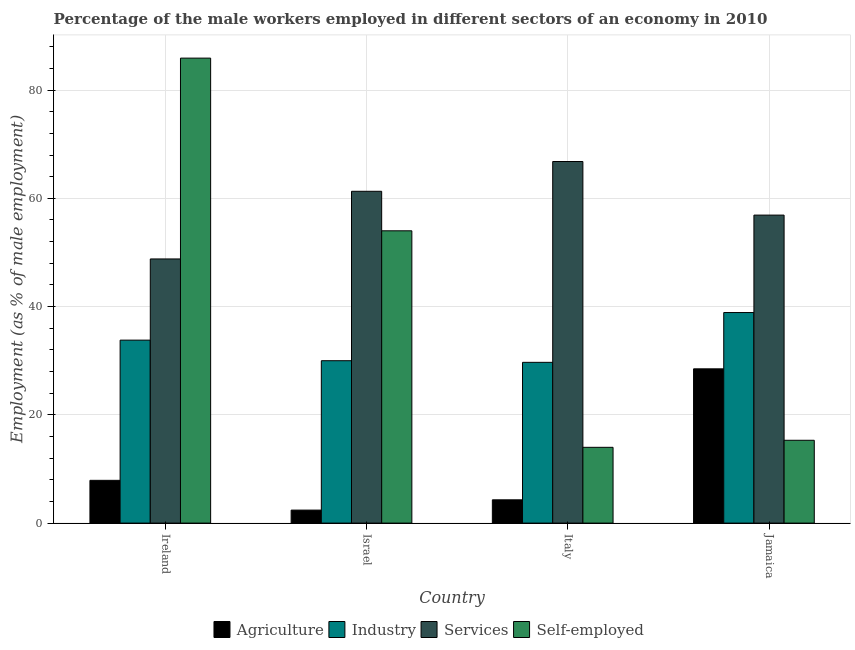How many groups of bars are there?
Your response must be concise. 4. Are the number of bars per tick equal to the number of legend labels?
Offer a very short reply. Yes. Are the number of bars on each tick of the X-axis equal?
Keep it short and to the point. Yes. How many bars are there on the 4th tick from the left?
Keep it short and to the point. 4. How many bars are there on the 1st tick from the right?
Your answer should be compact. 4. In how many cases, is the number of bars for a given country not equal to the number of legend labels?
Give a very brief answer. 0. What is the percentage of male workers in agriculture in Israel?
Give a very brief answer. 2.4. Across all countries, what is the maximum percentage of self employed male workers?
Your answer should be compact. 85.9. Across all countries, what is the minimum percentage of male workers in industry?
Make the answer very short. 29.7. What is the total percentage of male workers in agriculture in the graph?
Offer a very short reply. 43.1. What is the difference between the percentage of male workers in industry in Israel and that in Italy?
Make the answer very short. 0.3. What is the difference between the percentage of self employed male workers in Israel and the percentage of male workers in agriculture in Jamaica?
Give a very brief answer. 25.5. What is the average percentage of male workers in industry per country?
Keep it short and to the point. 33.1. What is the difference between the percentage of male workers in services and percentage of male workers in industry in Israel?
Offer a terse response. 31.3. In how many countries, is the percentage of male workers in industry greater than 76 %?
Offer a terse response. 0. What is the ratio of the percentage of self employed male workers in Ireland to that in Italy?
Offer a very short reply. 6.14. Is the percentage of male workers in industry in Israel less than that in Italy?
Your answer should be compact. No. Is the difference between the percentage of male workers in agriculture in Israel and Jamaica greater than the difference between the percentage of self employed male workers in Israel and Jamaica?
Make the answer very short. No. What is the difference between the highest and the second highest percentage of male workers in industry?
Ensure brevity in your answer.  5.1. What is the difference between the highest and the lowest percentage of self employed male workers?
Give a very brief answer. 71.9. What does the 3rd bar from the left in Jamaica represents?
Ensure brevity in your answer.  Services. What does the 2nd bar from the right in Jamaica represents?
Your answer should be compact. Services. Is it the case that in every country, the sum of the percentage of male workers in agriculture and percentage of male workers in industry is greater than the percentage of male workers in services?
Give a very brief answer. No. How many bars are there?
Offer a terse response. 16. Are all the bars in the graph horizontal?
Provide a succinct answer. No. How many countries are there in the graph?
Your answer should be compact. 4. What is the difference between two consecutive major ticks on the Y-axis?
Ensure brevity in your answer.  20. Are the values on the major ticks of Y-axis written in scientific E-notation?
Your answer should be compact. No. Does the graph contain any zero values?
Provide a short and direct response. No. How are the legend labels stacked?
Keep it short and to the point. Horizontal. What is the title of the graph?
Make the answer very short. Percentage of the male workers employed in different sectors of an economy in 2010. What is the label or title of the X-axis?
Your answer should be very brief. Country. What is the label or title of the Y-axis?
Your answer should be compact. Employment (as % of male employment). What is the Employment (as % of male employment) in Agriculture in Ireland?
Provide a short and direct response. 7.9. What is the Employment (as % of male employment) in Industry in Ireland?
Ensure brevity in your answer.  33.8. What is the Employment (as % of male employment) in Services in Ireland?
Provide a succinct answer. 48.8. What is the Employment (as % of male employment) in Self-employed in Ireland?
Ensure brevity in your answer.  85.9. What is the Employment (as % of male employment) in Agriculture in Israel?
Offer a terse response. 2.4. What is the Employment (as % of male employment) of Industry in Israel?
Keep it short and to the point. 30. What is the Employment (as % of male employment) in Services in Israel?
Offer a very short reply. 61.3. What is the Employment (as % of male employment) in Agriculture in Italy?
Ensure brevity in your answer.  4.3. What is the Employment (as % of male employment) of Industry in Italy?
Give a very brief answer. 29.7. What is the Employment (as % of male employment) of Services in Italy?
Ensure brevity in your answer.  66.8. What is the Employment (as % of male employment) in Industry in Jamaica?
Offer a terse response. 38.9. What is the Employment (as % of male employment) in Services in Jamaica?
Provide a succinct answer. 56.9. What is the Employment (as % of male employment) of Self-employed in Jamaica?
Your answer should be compact. 15.3. Across all countries, what is the maximum Employment (as % of male employment) in Industry?
Ensure brevity in your answer.  38.9. Across all countries, what is the maximum Employment (as % of male employment) in Services?
Provide a short and direct response. 66.8. Across all countries, what is the maximum Employment (as % of male employment) of Self-employed?
Offer a terse response. 85.9. Across all countries, what is the minimum Employment (as % of male employment) of Agriculture?
Provide a short and direct response. 2.4. Across all countries, what is the minimum Employment (as % of male employment) of Industry?
Your answer should be compact. 29.7. Across all countries, what is the minimum Employment (as % of male employment) of Services?
Ensure brevity in your answer.  48.8. What is the total Employment (as % of male employment) in Agriculture in the graph?
Keep it short and to the point. 43.1. What is the total Employment (as % of male employment) in Industry in the graph?
Keep it short and to the point. 132.4. What is the total Employment (as % of male employment) of Services in the graph?
Provide a short and direct response. 233.8. What is the total Employment (as % of male employment) of Self-employed in the graph?
Ensure brevity in your answer.  169.2. What is the difference between the Employment (as % of male employment) in Agriculture in Ireland and that in Israel?
Your answer should be compact. 5.5. What is the difference between the Employment (as % of male employment) of Services in Ireland and that in Israel?
Make the answer very short. -12.5. What is the difference between the Employment (as % of male employment) in Self-employed in Ireland and that in Israel?
Make the answer very short. 31.9. What is the difference between the Employment (as % of male employment) in Industry in Ireland and that in Italy?
Give a very brief answer. 4.1. What is the difference between the Employment (as % of male employment) of Self-employed in Ireland and that in Italy?
Keep it short and to the point. 71.9. What is the difference between the Employment (as % of male employment) of Agriculture in Ireland and that in Jamaica?
Give a very brief answer. -20.6. What is the difference between the Employment (as % of male employment) of Self-employed in Ireland and that in Jamaica?
Offer a very short reply. 70.6. What is the difference between the Employment (as % of male employment) of Agriculture in Israel and that in Italy?
Provide a short and direct response. -1.9. What is the difference between the Employment (as % of male employment) of Industry in Israel and that in Italy?
Offer a terse response. 0.3. What is the difference between the Employment (as % of male employment) of Services in Israel and that in Italy?
Your answer should be very brief. -5.5. What is the difference between the Employment (as % of male employment) of Self-employed in Israel and that in Italy?
Make the answer very short. 40. What is the difference between the Employment (as % of male employment) of Agriculture in Israel and that in Jamaica?
Your answer should be compact. -26.1. What is the difference between the Employment (as % of male employment) of Services in Israel and that in Jamaica?
Offer a terse response. 4.4. What is the difference between the Employment (as % of male employment) of Self-employed in Israel and that in Jamaica?
Offer a very short reply. 38.7. What is the difference between the Employment (as % of male employment) of Agriculture in Italy and that in Jamaica?
Give a very brief answer. -24.2. What is the difference between the Employment (as % of male employment) in Agriculture in Ireland and the Employment (as % of male employment) in Industry in Israel?
Offer a very short reply. -22.1. What is the difference between the Employment (as % of male employment) of Agriculture in Ireland and the Employment (as % of male employment) of Services in Israel?
Your answer should be compact. -53.4. What is the difference between the Employment (as % of male employment) of Agriculture in Ireland and the Employment (as % of male employment) of Self-employed in Israel?
Ensure brevity in your answer.  -46.1. What is the difference between the Employment (as % of male employment) in Industry in Ireland and the Employment (as % of male employment) in Services in Israel?
Offer a terse response. -27.5. What is the difference between the Employment (as % of male employment) in Industry in Ireland and the Employment (as % of male employment) in Self-employed in Israel?
Your answer should be compact. -20.2. What is the difference between the Employment (as % of male employment) in Agriculture in Ireland and the Employment (as % of male employment) in Industry in Italy?
Give a very brief answer. -21.8. What is the difference between the Employment (as % of male employment) of Agriculture in Ireland and the Employment (as % of male employment) of Services in Italy?
Provide a succinct answer. -58.9. What is the difference between the Employment (as % of male employment) in Agriculture in Ireland and the Employment (as % of male employment) in Self-employed in Italy?
Provide a succinct answer. -6.1. What is the difference between the Employment (as % of male employment) in Industry in Ireland and the Employment (as % of male employment) in Services in Italy?
Your response must be concise. -33. What is the difference between the Employment (as % of male employment) in Industry in Ireland and the Employment (as % of male employment) in Self-employed in Italy?
Provide a short and direct response. 19.8. What is the difference between the Employment (as % of male employment) in Services in Ireland and the Employment (as % of male employment) in Self-employed in Italy?
Ensure brevity in your answer.  34.8. What is the difference between the Employment (as % of male employment) in Agriculture in Ireland and the Employment (as % of male employment) in Industry in Jamaica?
Make the answer very short. -31. What is the difference between the Employment (as % of male employment) of Agriculture in Ireland and the Employment (as % of male employment) of Services in Jamaica?
Your answer should be compact. -49. What is the difference between the Employment (as % of male employment) in Industry in Ireland and the Employment (as % of male employment) in Services in Jamaica?
Your answer should be very brief. -23.1. What is the difference between the Employment (as % of male employment) of Services in Ireland and the Employment (as % of male employment) of Self-employed in Jamaica?
Make the answer very short. 33.5. What is the difference between the Employment (as % of male employment) of Agriculture in Israel and the Employment (as % of male employment) of Industry in Italy?
Provide a short and direct response. -27.3. What is the difference between the Employment (as % of male employment) of Agriculture in Israel and the Employment (as % of male employment) of Services in Italy?
Your answer should be compact. -64.4. What is the difference between the Employment (as % of male employment) of Agriculture in Israel and the Employment (as % of male employment) of Self-employed in Italy?
Keep it short and to the point. -11.6. What is the difference between the Employment (as % of male employment) of Industry in Israel and the Employment (as % of male employment) of Services in Italy?
Offer a terse response. -36.8. What is the difference between the Employment (as % of male employment) of Services in Israel and the Employment (as % of male employment) of Self-employed in Italy?
Offer a terse response. 47.3. What is the difference between the Employment (as % of male employment) in Agriculture in Israel and the Employment (as % of male employment) in Industry in Jamaica?
Provide a short and direct response. -36.5. What is the difference between the Employment (as % of male employment) of Agriculture in Israel and the Employment (as % of male employment) of Services in Jamaica?
Your answer should be compact. -54.5. What is the difference between the Employment (as % of male employment) of Agriculture in Israel and the Employment (as % of male employment) of Self-employed in Jamaica?
Keep it short and to the point. -12.9. What is the difference between the Employment (as % of male employment) of Industry in Israel and the Employment (as % of male employment) of Services in Jamaica?
Keep it short and to the point. -26.9. What is the difference between the Employment (as % of male employment) in Services in Israel and the Employment (as % of male employment) in Self-employed in Jamaica?
Make the answer very short. 46. What is the difference between the Employment (as % of male employment) in Agriculture in Italy and the Employment (as % of male employment) in Industry in Jamaica?
Ensure brevity in your answer.  -34.6. What is the difference between the Employment (as % of male employment) in Agriculture in Italy and the Employment (as % of male employment) in Services in Jamaica?
Give a very brief answer. -52.6. What is the difference between the Employment (as % of male employment) of Agriculture in Italy and the Employment (as % of male employment) of Self-employed in Jamaica?
Keep it short and to the point. -11. What is the difference between the Employment (as % of male employment) in Industry in Italy and the Employment (as % of male employment) in Services in Jamaica?
Offer a very short reply. -27.2. What is the difference between the Employment (as % of male employment) of Services in Italy and the Employment (as % of male employment) of Self-employed in Jamaica?
Offer a very short reply. 51.5. What is the average Employment (as % of male employment) in Agriculture per country?
Your answer should be very brief. 10.78. What is the average Employment (as % of male employment) in Industry per country?
Offer a very short reply. 33.1. What is the average Employment (as % of male employment) in Services per country?
Keep it short and to the point. 58.45. What is the average Employment (as % of male employment) in Self-employed per country?
Your response must be concise. 42.3. What is the difference between the Employment (as % of male employment) in Agriculture and Employment (as % of male employment) in Industry in Ireland?
Give a very brief answer. -25.9. What is the difference between the Employment (as % of male employment) of Agriculture and Employment (as % of male employment) of Services in Ireland?
Provide a succinct answer. -40.9. What is the difference between the Employment (as % of male employment) of Agriculture and Employment (as % of male employment) of Self-employed in Ireland?
Your answer should be compact. -78. What is the difference between the Employment (as % of male employment) of Industry and Employment (as % of male employment) of Services in Ireland?
Ensure brevity in your answer.  -15. What is the difference between the Employment (as % of male employment) of Industry and Employment (as % of male employment) of Self-employed in Ireland?
Your response must be concise. -52.1. What is the difference between the Employment (as % of male employment) in Services and Employment (as % of male employment) in Self-employed in Ireland?
Make the answer very short. -37.1. What is the difference between the Employment (as % of male employment) of Agriculture and Employment (as % of male employment) of Industry in Israel?
Keep it short and to the point. -27.6. What is the difference between the Employment (as % of male employment) in Agriculture and Employment (as % of male employment) in Services in Israel?
Offer a terse response. -58.9. What is the difference between the Employment (as % of male employment) of Agriculture and Employment (as % of male employment) of Self-employed in Israel?
Provide a succinct answer. -51.6. What is the difference between the Employment (as % of male employment) in Industry and Employment (as % of male employment) in Services in Israel?
Keep it short and to the point. -31.3. What is the difference between the Employment (as % of male employment) of Industry and Employment (as % of male employment) of Self-employed in Israel?
Offer a terse response. -24. What is the difference between the Employment (as % of male employment) in Services and Employment (as % of male employment) in Self-employed in Israel?
Keep it short and to the point. 7.3. What is the difference between the Employment (as % of male employment) in Agriculture and Employment (as % of male employment) in Industry in Italy?
Make the answer very short. -25.4. What is the difference between the Employment (as % of male employment) of Agriculture and Employment (as % of male employment) of Services in Italy?
Give a very brief answer. -62.5. What is the difference between the Employment (as % of male employment) of Agriculture and Employment (as % of male employment) of Self-employed in Italy?
Your answer should be compact. -9.7. What is the difference between the Employment (as % of male employment) of Industry and Employment (as % of male employment) of Services in Italy?
Offer a very short reply. -37.1. What is the difference between the Employment (as % of male employment) of Industry and Employment (as % of male employment) of Self-employed in Italy?
Your answer should be very brief. 15.7. What is the difference between the Employment (as % of male employment) of Services and Employment (as % of male employment) of Self-employed in Italy?
Your answer should be very brief. 52.8. What is the difference between the Employment (as % of male employment) of Agriculture and Employment (as % of male employment) of Services in Jamaica?
Offer a very short reply. -28.4. What is the difference between the Employment (as % of male employment) of Industry and Employment (as % of male employment) of Services in Jamaica?
Make the answer very short. -18. What is the difference between the Employment (as % of male employment) in Industry and Employment (as % of male employment) in Self-employed in Jamaica?
Your answer should be compact. 23.6. What is the difference between the Employment (as % of male employment) in Services and Employment (as % of male employment) in Self-employed in Jamaica?
Give a very brief answer. 41.6. What is the ratio of the Employment (as % of male employment) in Agriculture in Ireland to that in Israel?
Your answer should be compact. 3.29. What is the ratio of the Employment (as % of male employment) of Industry in Ireland to that in Israel?
Provide a succinct answer. 1.13. What is the ratio of the Employment (as % of male employment) of Services in Ireland to that in Israel?
Ensure brevity in your answer.  0.8. What is the ratio of the Employment (as % of male employment) of Self-employed in Ireland to that in Israel?
Offer a very short reply. 1.59. What is the ratio of the Employment (as % of male employment) in Agriculture in Ireland to that in Italy?
Ensure brevity in your answer.  1.84. What is the ratio of the Employment (as % of male employment) in Industry in Ireland to that in Italy?
Ensure brevity in your answer.  1.14. What is the ratio of the Employment (as % of male employment) of Services in Ireland to that in Italy?
Provide a succinct answer. 0.73. What is the ratio of the Employment (as % of male employment) in Self-employed in Ireland to that in Italy?
Keep it short and to the point. 6.14. What is the ratio of the Employment (as % of male employment) in Agriculture in Ireland to that in Jamaica?
Keep it short and to the point. 0.28. What is the ratio of the Employment (as % of male employment) in Industry in Ireland to that in Jamaica?
Make the answer very short. 0.87. What is the ratio of the Employment (as % of male employment) in Services in Ireland to that in Jamaica?
Give a very brief answer. 0.86. What is the ratio of the Employment (as % of male employment) in Self-employed in Ireland to that in Jamaica?
Your answer should be very brief. 5.61. What is the ratio of the Employment (as % of male employment) of Agriculture in Israel to that in Italy?
Make the answer very short. 0.56. What is the ratio of the Employment (as % of male employment) of Industry in Israel to that in Italy?
Give a very brief answer. 1.01. What is the ratio of the Employment (as % of male employment) in Services in Israel to that in Italy?
Your answer should be very brief. 0.92. What is the ratio of the Employment (as % of male employment) of Self-employed in Israel to that in Italy?
Your response must be concise. 3.86. What is the ratio of the Employment (as % of male employment) in Agriculture in Israel to that in Jamaica?
Make the answer very short. 0.08. What is the ratio of the Employment (as % of male employment) of Industry in Israel to that in Jamaica?
Keep it short and to the point. 0.77. What is the ratio of the Employment (as % of male employment) of Services in Israel to that in Jamaica?
Your answer should be compact. 1.08. What is the ratio of the Employment (as % of male employment) of Self-employed in Israel to that in Jamaica?
Your answer should be very brief. 3.53. What is the ratio of the Employment (as % of male employment) in Agriculture in Italy to that in Jamaica?
Give a very brief answer. 0.15. What is the ratio of the Employment (as % of male employment) of Industry in Italy to that in Jamaica?
Make the answer very short. 0.76. What is the ratio of the Employment (as % of male employment) of Services in Italy to that in Jamaica?
Ensure brevity in your answer.  1.17. What is the ratio of the Employment (as % of male employment) of Self-employed in Italy to that in Jamaica?
Offer a very short reply. 0.92. What is the difference between the highest and the second highest Employment (as % of male employment) in Agriculture?
Your answer should be compact. 20.6. What is the difference between the highest and the second highest Employment (as % of male employment) in Industry?
Provide a succinct answer. 5.1. What is the difference between the highest and the second highest Employment (as % of male employment) in Services?
Offer a very short reply. 5.5. What is the difference between the highest and the second highest Employment (as % of male employment) in Self-employed?
Ensure brevity in your answer.  31.9. What is the difference between the highest and the lowest Employment (as % of male employment) of Agriculture?
Offer a very short reply. 26.1. What is the difference between the highest and the lowest Employment (as % of male employment) in Self-employed?
Your answer should be very brief. 71.9. 